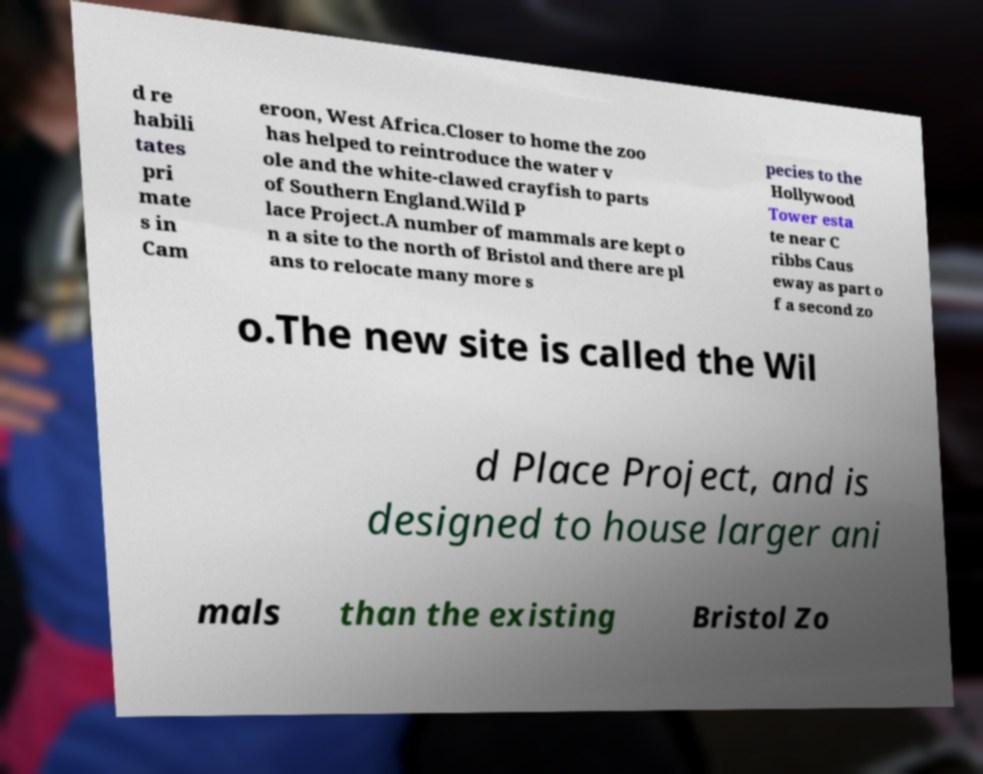Can you read and provide the text displayed in the image?This photo seems to have some interesting text. Can you extract and type it out for me? d re habili tates pri mate s in Cam eroon, West Africa.Closer to home the zoo has helped to reintroduce the water v ole and the white-clawed crayfish to parts of Southern England.Wild P lace Project.A number of mammals are kept o n a site to the north of Bristol and there are pl ans to relocate many more s pecies to the Hollywood Tower esta te near C ribbs Caus eway as part o f a second zo o.The new site is called the Wil d Place Project, and is designed to house larger ani mals than the existing Bristol Zo 